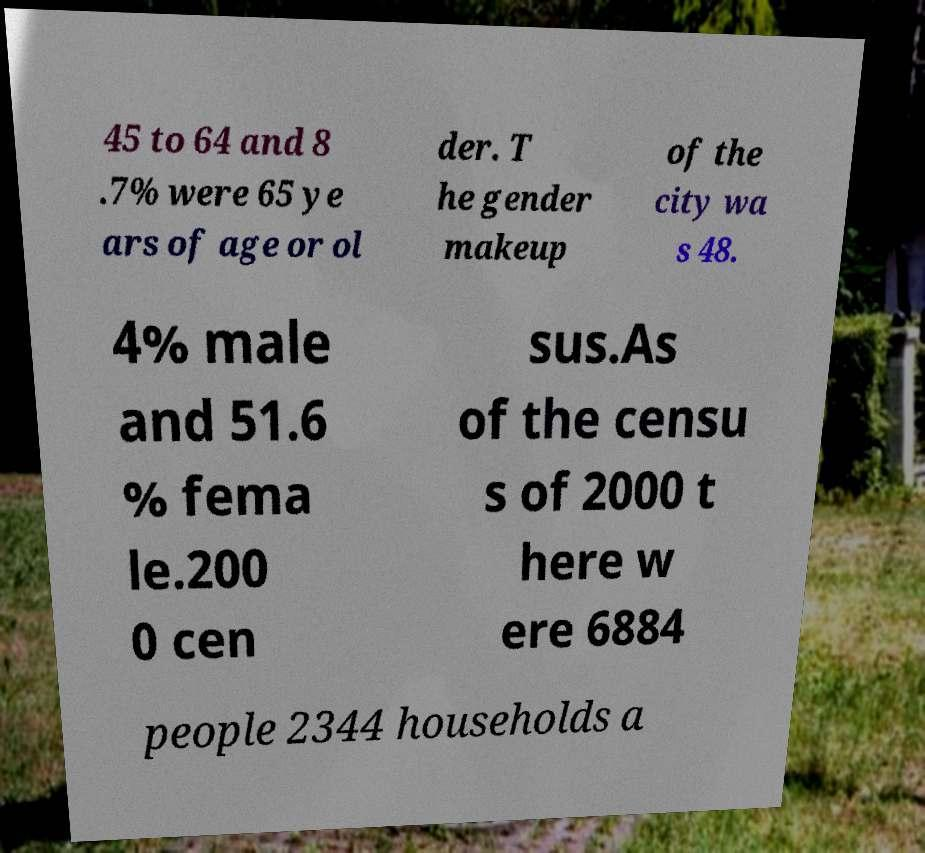Could you extract and type out the text from this image? 45 to 64 and 8 .7% were 65 ye ars of age or ol der. T he gender makeup of the city wa s 48. 4% male and 51.6 % fema le.200 0 cen sus.As of the censu s of 2000 t here w ere 6884 people 2344 households a 